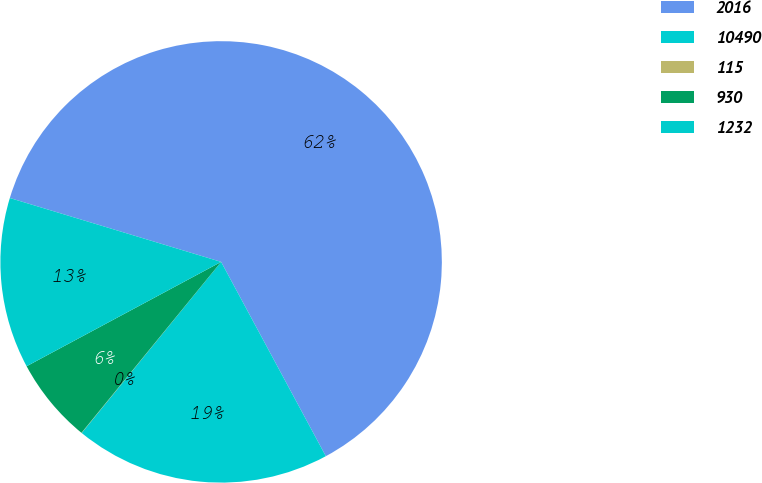Convert chart. <chart><loc_0><loc_0><loc_500><loc_500><pie_chart><fcel>2016<fcel>10490<fcel>115<fcel>930<fcel>1232<nl><fcel>62.46%<fcel>18.75%<fcel>0.02%<fcel>6.26%<fcel>12.51%<nl></chart> 